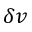Convert formula to latex. <formula><loc_0><loc_0><loc_500><loc_500>\delta v</formula> 